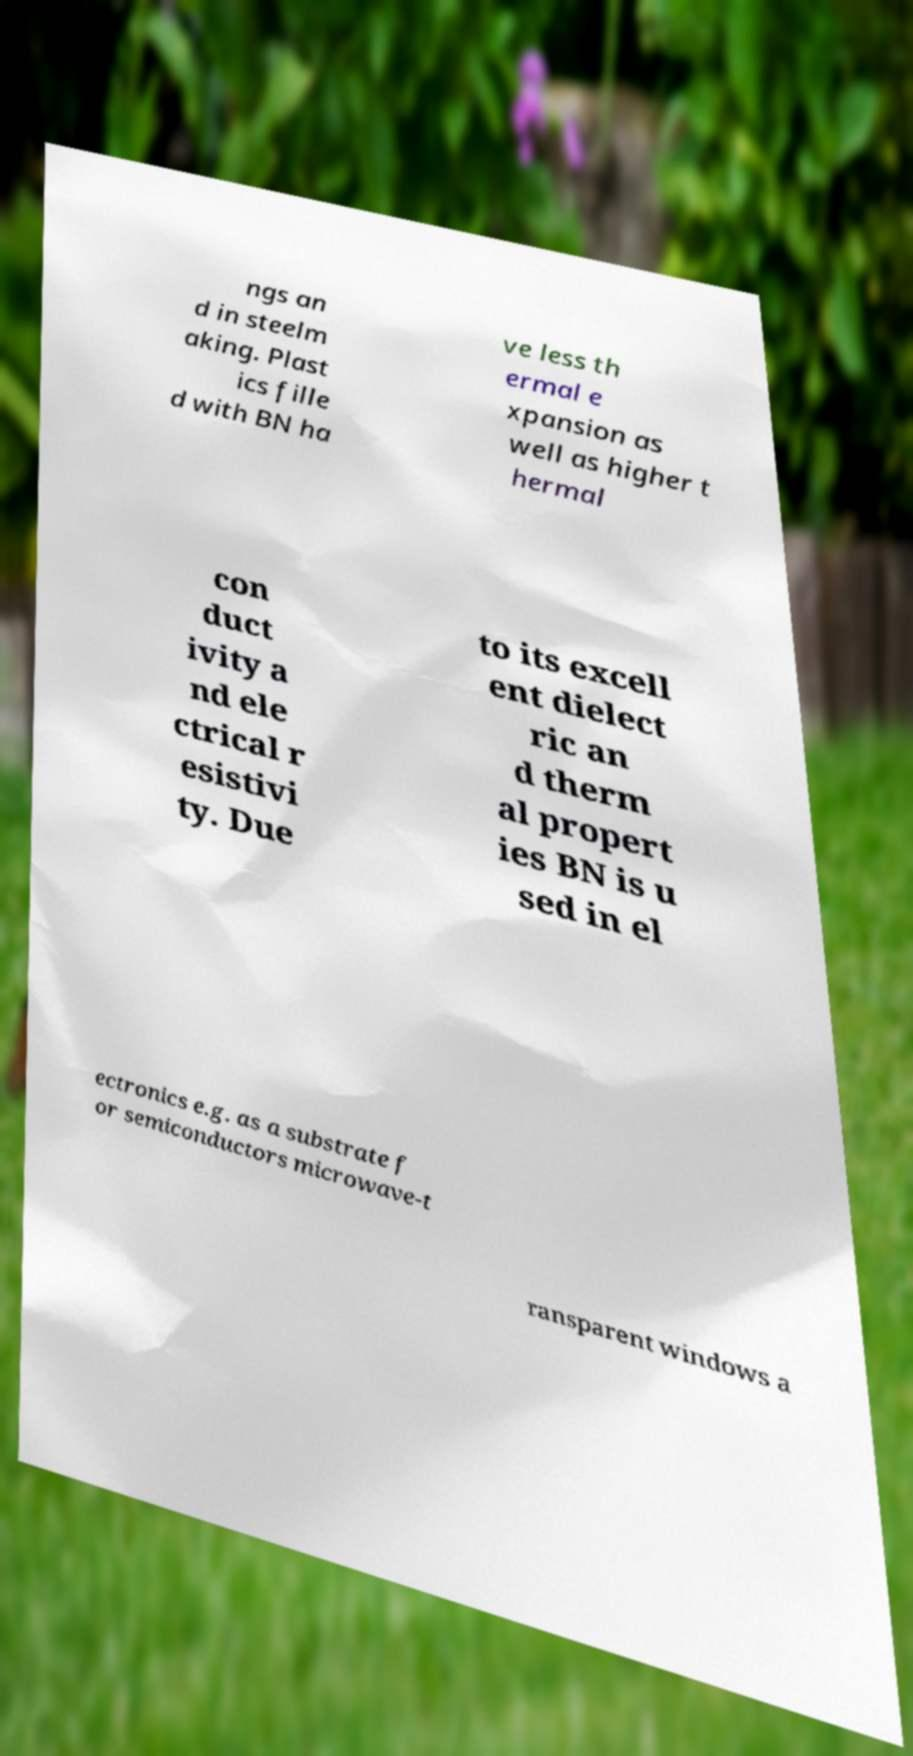For documentation purposes, I need the text within this image transcribed. Could you provide that? ngs an d in steelm aking. Plast ics fille d with BN ha ve less th ermal e xpansion as well as higher t hermal con duct ivity a nd ele ctrical r esistivi ty. Due to its excell ent dielect ric an d therm al propert ies BN is u sed in el ectronics e.g. as a substrate f or semiconductors microwave-t ransparent windows a 